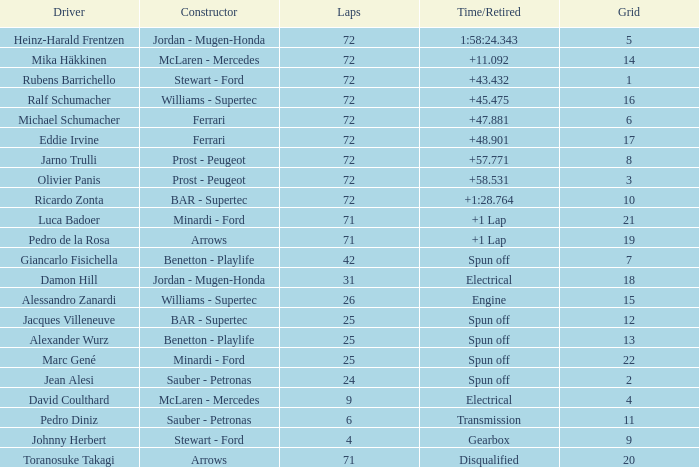Give me the full table as a dictionary. {'header': ['Driver', 'Constructor', 'Laps', 'Time/Retired', 'Grid'], 'rows': [['Heinz-Harald Frentzen', 'Jordan - Mugen-Honda', '72', '1:58:24.343', '5'], ['Mika Häkkinen', 'McLaren - Mercedes', '72', '+11.092', '14'], ['Rubens Barrichello', 'Stewart - Ford', '72', '+43.432', '1'], ['Ralf Schumacher', 'Williams - Supertec', '72', '+45.475', '16'], ['Michael Schumacher', 'Ferrari', '72', '+47.881', '6'], ['Eddie Irvine', 'Ferrari', '72', '+48.901', '17'], ['Jarno Trulli', 'Prost - Peugeot', '72', '+57.771', '8'], ['Olivier Panis', 'Prost - Peugeot', '72', '+58.531', '3'], ['Ricardo Zonta', 'BAR - Supertec', '72', '+1:28.764', '10'], ['Luca Badoer', 'Minardi - Ford', '71', '+1 Lap', '21'], ['Pedro de la Rosa', 'Arrows', '71', '+1 Lap', '19'], ['Giancarlo Fisichella', 'Benetton - Playlife', '42', 'Spun off', '7'], ['Damon Hill', 'Jordan - Mugen-Honda', '31', 'Electrical', '18'], ['Alessandro Zanardi', 'Williams - Supertec', '26', 'Engine', '15'], ['Jacques Villeneuve', 'BAR - Supertec', '25', 'Spun off', '12'], ['Alexander Wurz', 'Benetton - Playlife', '25', 'Spun off', '13'], ['Marc Gené', 'Minardi - Ford', '25', 'Spun off', '22'], ['Jean Alesi', 'Sauber - Petronas', '24', 'Spun off', '2'], ['David Coulthard', 'McLaren - Mercedes', '9', 'Electrical', '4'], ['Pedro Diniz', 'Sauber - Petronas', '6', 'Transmission', '11'], ['Johnny Herbert', 'Stewart - Ford', '4', 'Gearbox', '9'], ['Toranosuke Takagi', 'Arrows', '71', 'Disqualified', '20']]} When jean alesi finished fewer than 24 laps, what was his best grid placement? None. 